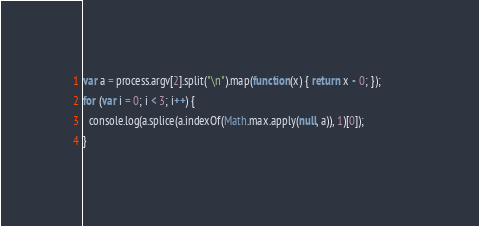<code> <loc_0><loc_0><loc_500><loc_500><_JavaScript_>var a = process.argv[2].split("\n").map(function(x) { return x - 0; });         
for (var i = 0; i < 3; i++) {                                                   
  console.log(a.splice(a.indexOf(Math.max.apply(null, a)), 1)[0]);              
} </code> 